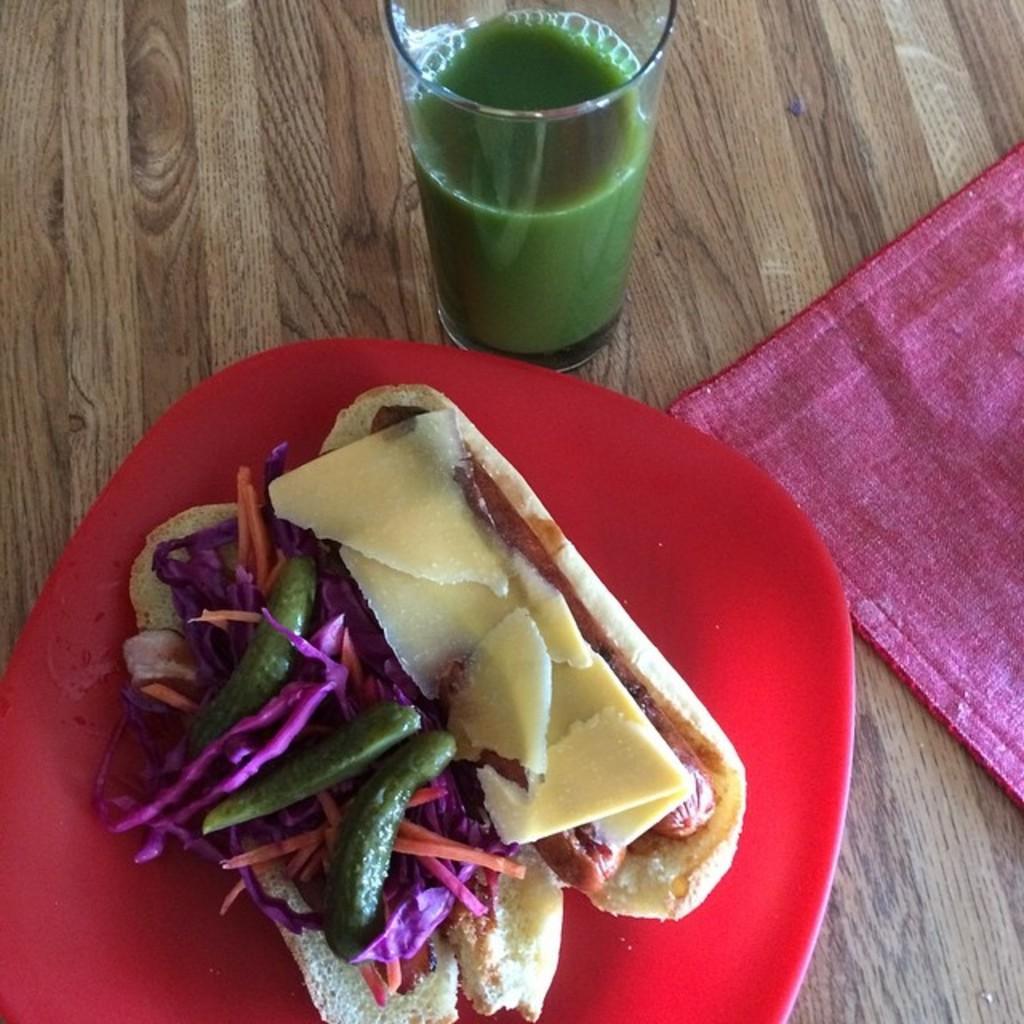Describe this image in one or two sentences. In this image we can see a food item is kept in a red color plate. Beside it one napkin is there and one glass full of green juice is present. 